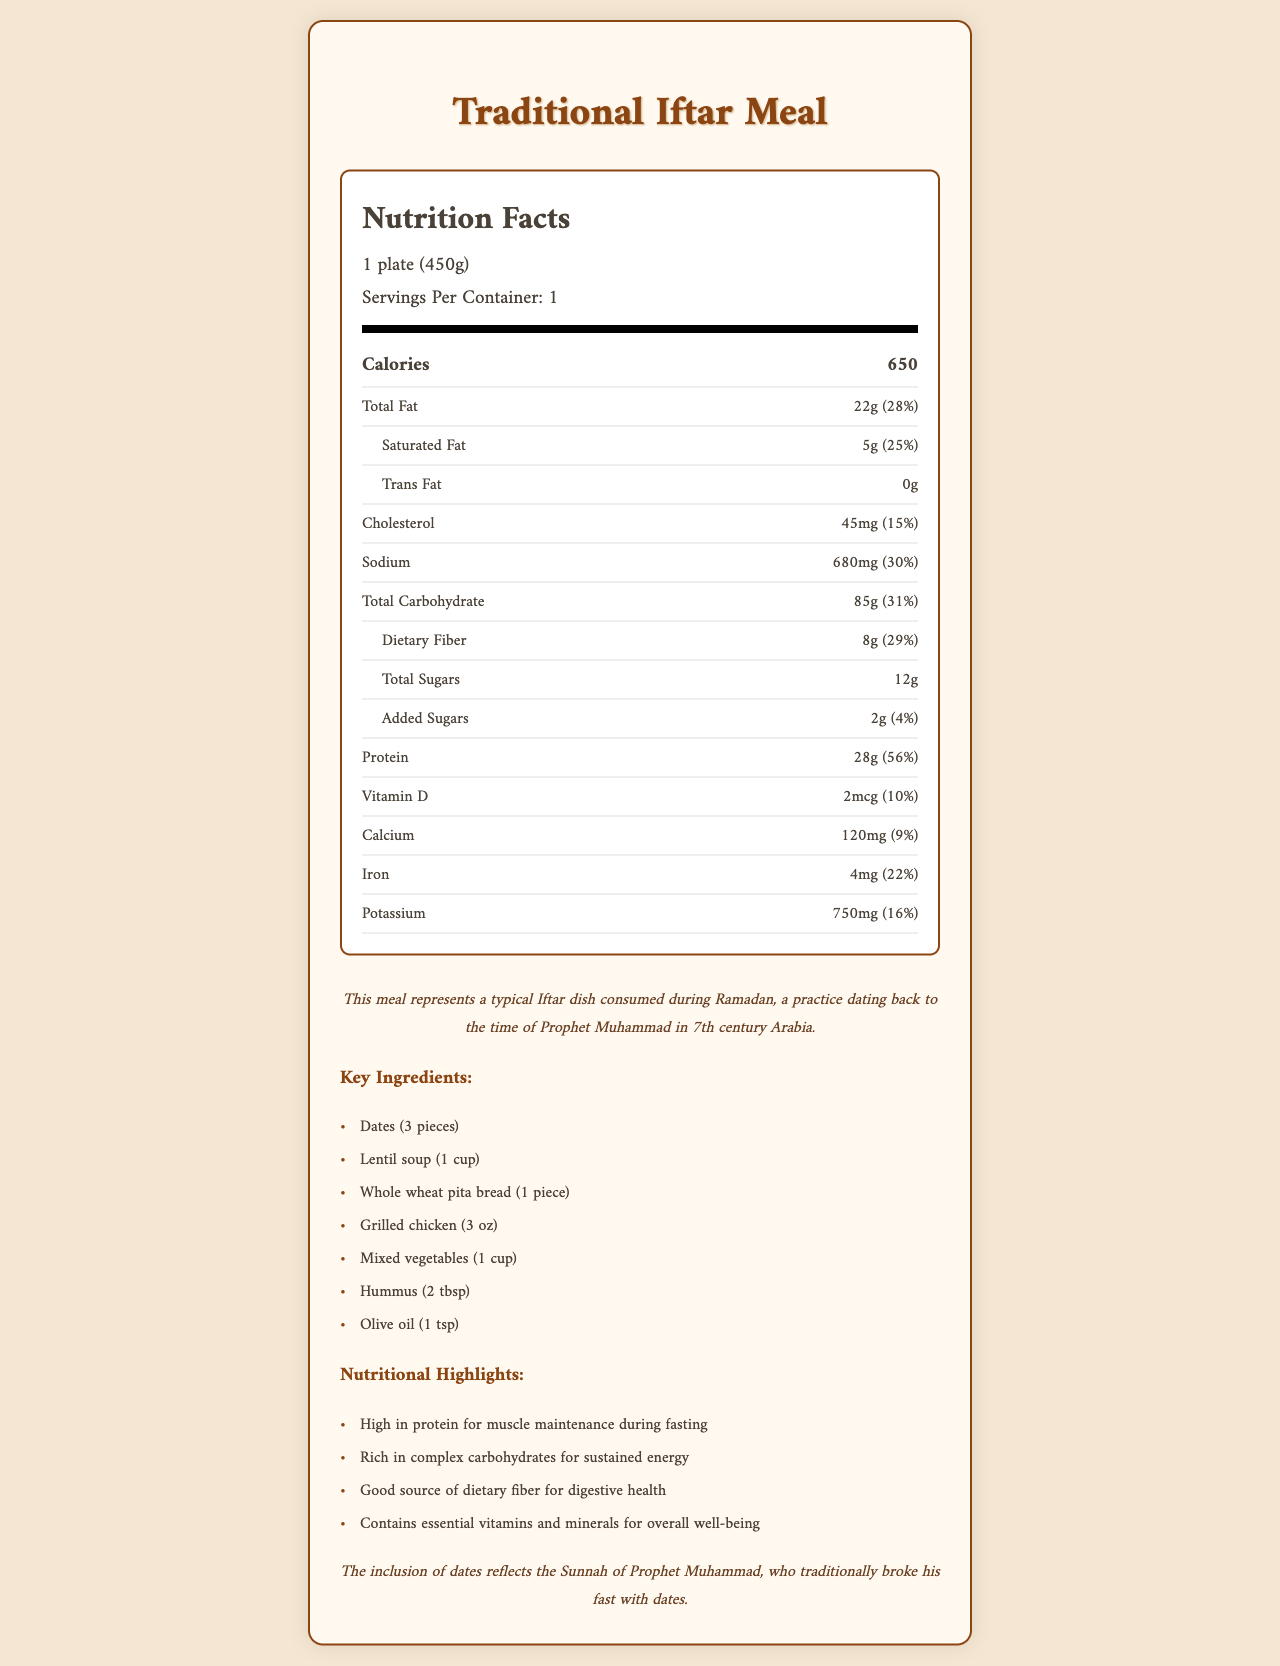what is the serving size for the Traditional Iftar Meal? The serving size for the Traditional Iftar Meal is indicated as 1 plate (450g) in the document.
Answer: 1 plate (450g) how many calories are in one serving of the Traditional Iftar Meal? The document specifies that there are 650 calories per serving in the Traditional Iftar Meal.
Answer: 650 calories what is the total fat content and its percent daily value in one serving? The document shows that the total fat content is 22g, which is 28% of the daily value per serving.
Answer: 22g (28%) how much protein does one serving of the Traditional Iftar Meal provide? The protein content per serving is listed as 28g in the document.
Answer: 28g which ingredient is specifically noted for breaking the fast according to the Sunnah of Prophet Muhammad? The document mentions that dates are included to reflect the Sunnah of Prophet Muhammad.
Answer: Dates (3 pieces) what is the percent daily value of dietary fiber in one serving? According to the document, the percent daily value of dietary fiber is 29%.
Answer: 29% which nutrient has the highest percent daily value in the Traditional Iftar Meal? The document indicates that protein has the highest percent daily value at 56%.
Answer: Protein how much sodium does one serving contain? The sodium content is listed as 680mg, which represents 30% of the daily value per serving.
Answer: 680mg (30%) how has the Iftar meal evolved over centuries? The document mentions that the Iftar meal has evolved by incorporating local ingredients while maintaining the core nutritional principles established during early Islamic periods.
Answer: It has incorporated local ingredients while maintaining core nutritional principles from early Islamic periods. what are the nutritional highlights of the Traditional Iftar Meal? (select all that apply) A. High in protein B. Low in carbohydrates C. Good source of dietary fiber D. Low in fat The nutritional highlights listed in the document include high in protein (A) and a good source of dietary fiber (C).
Answer: A, C which of the following nutrients is least present in the Traditional Iftar Meal? A. Vitamin D B. Calcium C. Iron D. Potassium The document shows that Vitamin D is present in the smallest amount at 2mcg.
Answer: A. Vitamin D is the Traditional Iftar Meal accepted across various Islamic sects? The document states that the meal is generally accepted across different Islamic sects, promoting unity in fasting practices.
Answer: Yes describe the main idea of the document. The document outlines the nutritional content of a Traditional Iftar Meal, its key ingredients, nutritional highlights, cultural and historical context, sectarian considerations, and its evolution over time.
Answer: The document provides detailed nutritional information about a Traditional Iftar Meal, highlighting its key nutrients, historical context, cultural significance, and how it supports fasting practices during Ramadan. what is the source of the local ingredients mentioned in the document's historical evolution? The document does not specify the source of the local ingredients; it only mentions that the meal has incorporated local ingredients over centuries.
Answer: Cannot be determined what is the amount of added sugars in the Traditional Iftar Meal? The added sugars content in the document is listed as 2g, which is 4% of the daily value per serving.
Answer: 2g (4%) 